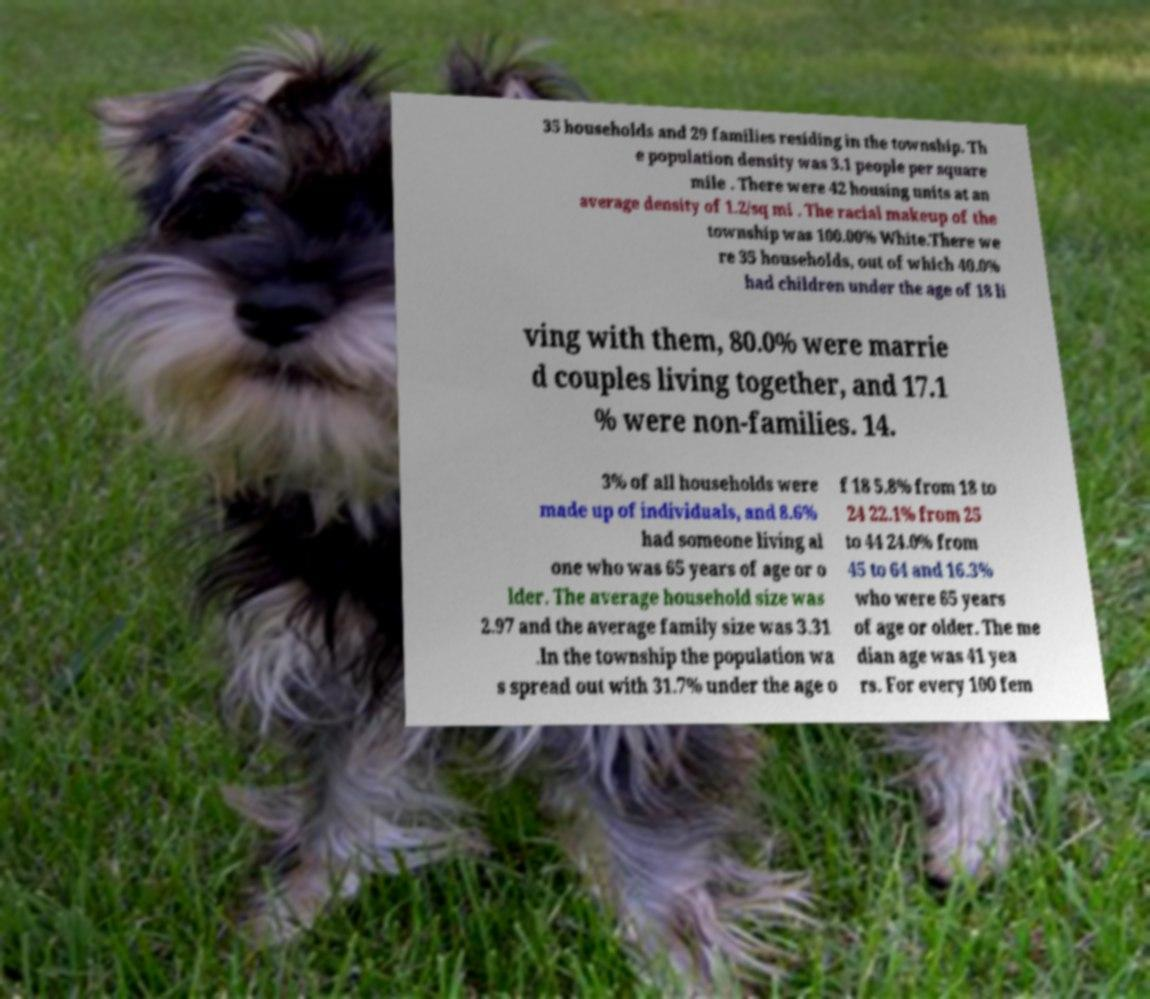I need the written content from this picture converted into text. Can you do that? 35 households and 29 families residing in the township. Th e population density was 3.1 people per square mile . There were 42 housing units at an average density of 1.2/sq mi . The racial makeup of the township was 100.00% White.There we re 35 households, out of which 40.0% had children under the age of 18 li ving with them, 80.0% were marrie d couples living together, and 17.1 % were non-families. 14. 3% of all households were made up of individuals, and 8.6% had someone living al one who was 65 years of age or o lder. The average household size was 2.97 and the average family size was 3.31 .In the township the population wa s spread out with 31.7% under the age o f 18 5.8% from 18 to 24 22.1% from 25 to 44 24.0% from 45 to 64 and 16.3% who were 65 years of age or older. The me dian age was 41 yea rs. For every 100 fem 